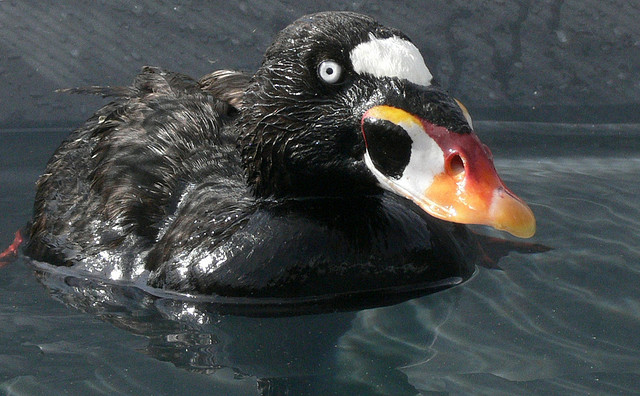<image>What type of duck is this? I don't know what type of duck this is. It can be a mallard or a black duck. What type of duck is this? I am not sure about the type of duck in the image. 